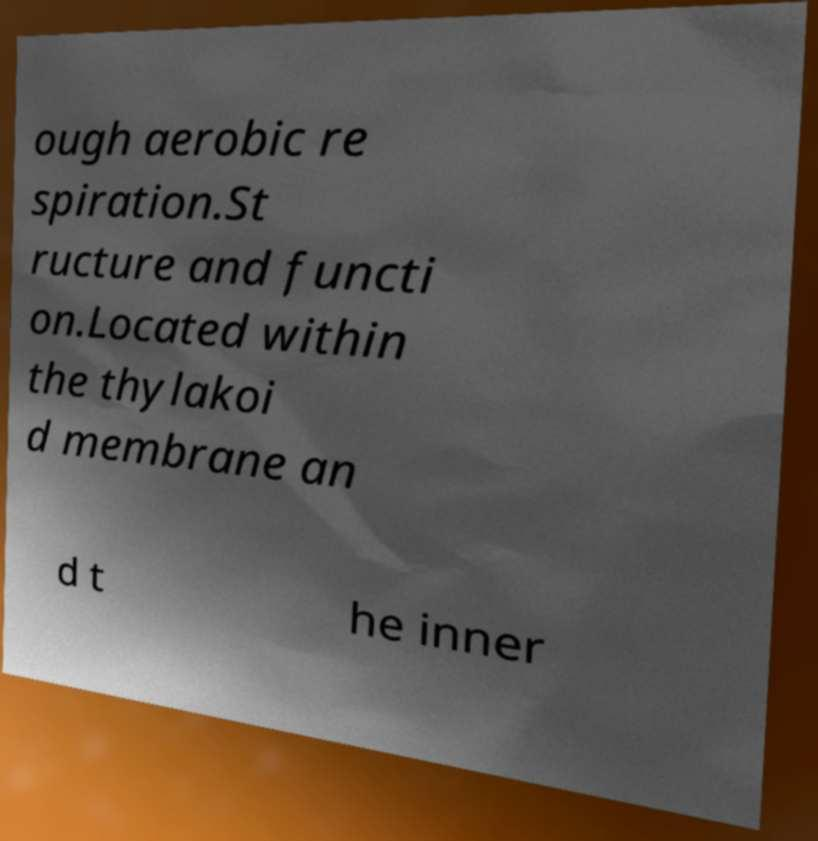Please identify and transcribe the text found in this image. ough aerobic re spiration.St ructure and functi on.Located within the thylakoi d membrane an d t he inner 